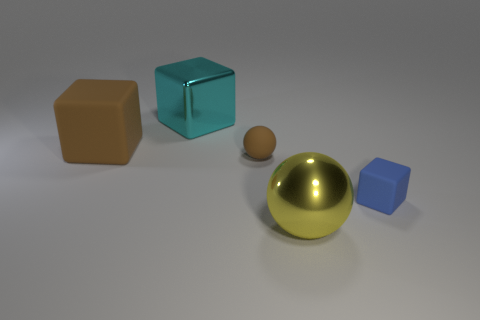Add 1 blocks. How many objects exist? 6 Subtract all blocks. How many objects are left? 2 Subtract all big blue things. Subtract all metal cubes. How many objects are left? 4 Add 2 yellow shiny balls. How many yellow shiny balls are left? 3 Add 5 small green metal blocks. How many small green metal blocks exist? 5 Subtract 0 purple cylinders. How many objects are left? 5 